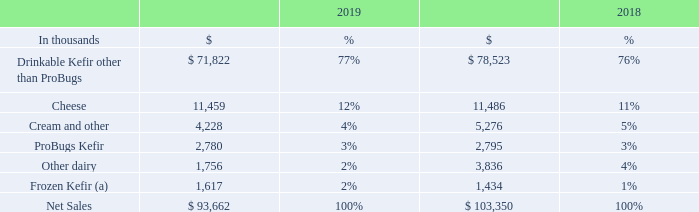Our product categories are:
Drinkable Kefir, sold in a variety of organic and non-organic sizes, flavors, and types, including low fat, non-fat, whole milk, protein, and BioKefir (a 3.5 oz. kefir with additional probiotic cultures).
European-style soft cheeses, including farmer cheese in resealable cups.
Cream and other, which consists primarily of cream, a byproduct of making our kefir.
ProBugs, a line of kefir products designed for children.
Other Dairy, which includes Cupped Kefir and Icelandic Skyr, a line of strained kefir and yogurt products in resealable cups.
Frozen Kefir, available in soft serve and pint-size containers.
Lifeway has determined that it has one reportable segment based on how our chief operating decision maker manages the business and in a manner consistent with the internal reporting provided to the chief operating decision maker. The chief operating decision maker, who is responsible for allocating resources and assessing our performance, has been identified collectively as the Chief Financial Officer, the Chief Operating Officer, the Chief Executive Officer, and Chairperson of the board of directors. Substantially all of our consolidated revenues relate to the sale of cultured dairy products that we produce using the same processes and materials and are sold to consumers through a common network of distributors and retailers in the United States.
Net sales of products by category were as follows for the years ended December 31:
(a) Includes Lifeway Kefir Shop sales
Significant Customers – Sales are predominately to companies in the retail food industry located within the United States. Two major customers accounted for approximately 22% and 21% of net sales for the years ended December 31, 2019 and 2018, respectively. Two major customers accounted for approximately 17% of accounts receivable as of December 31, 2019 and 2018. Our ten largest customers as a group accounted for approximately 57% and 59% of net sales for the years ended December 31, 2019 and 2018, respectively.
What is net sales from cheese in 2018 and 2019 respectively?
Answer scale should be: thousand. 11,486, 11,459. What is net sales from cream and other in 2018 and 2019 respectively?
Answer scale should be: thousand. 5,276, 4,228. What is net sales from ProBugs Kefir in 2018 and 2019 respectively?
Answer scale should be: thousand. 2,795, 2,780. How many product categories are available? Drinkable Kefir other than ProBugs ## Cheese ## Cream and other ## ProBugs Kefir ## Other dairy ## Frozen Kefir
Answer: 6. What is the change in the net sales for cheese between 2018 and 2019?
Answer scale should be: thousand.  11,459 - 11,486 
Answer: -27. What is the percentage change in net sales from Frozen Kefir between 2018 and 2019?
Answer scale should be: percent. (1,617-1,434)/1,434
Answer: 12.76. 